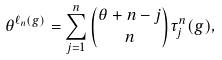Convert formula to latex. <formula><loc_0><loc_0><loc_500><loc_500>\theta ^ { \ell _ { n } ( g ) } = \sum _ { j = 1 } ^ { n } { \theta + n - j \choose n } \tau _ { j } ^ { n } ( g ) ,</formula> 